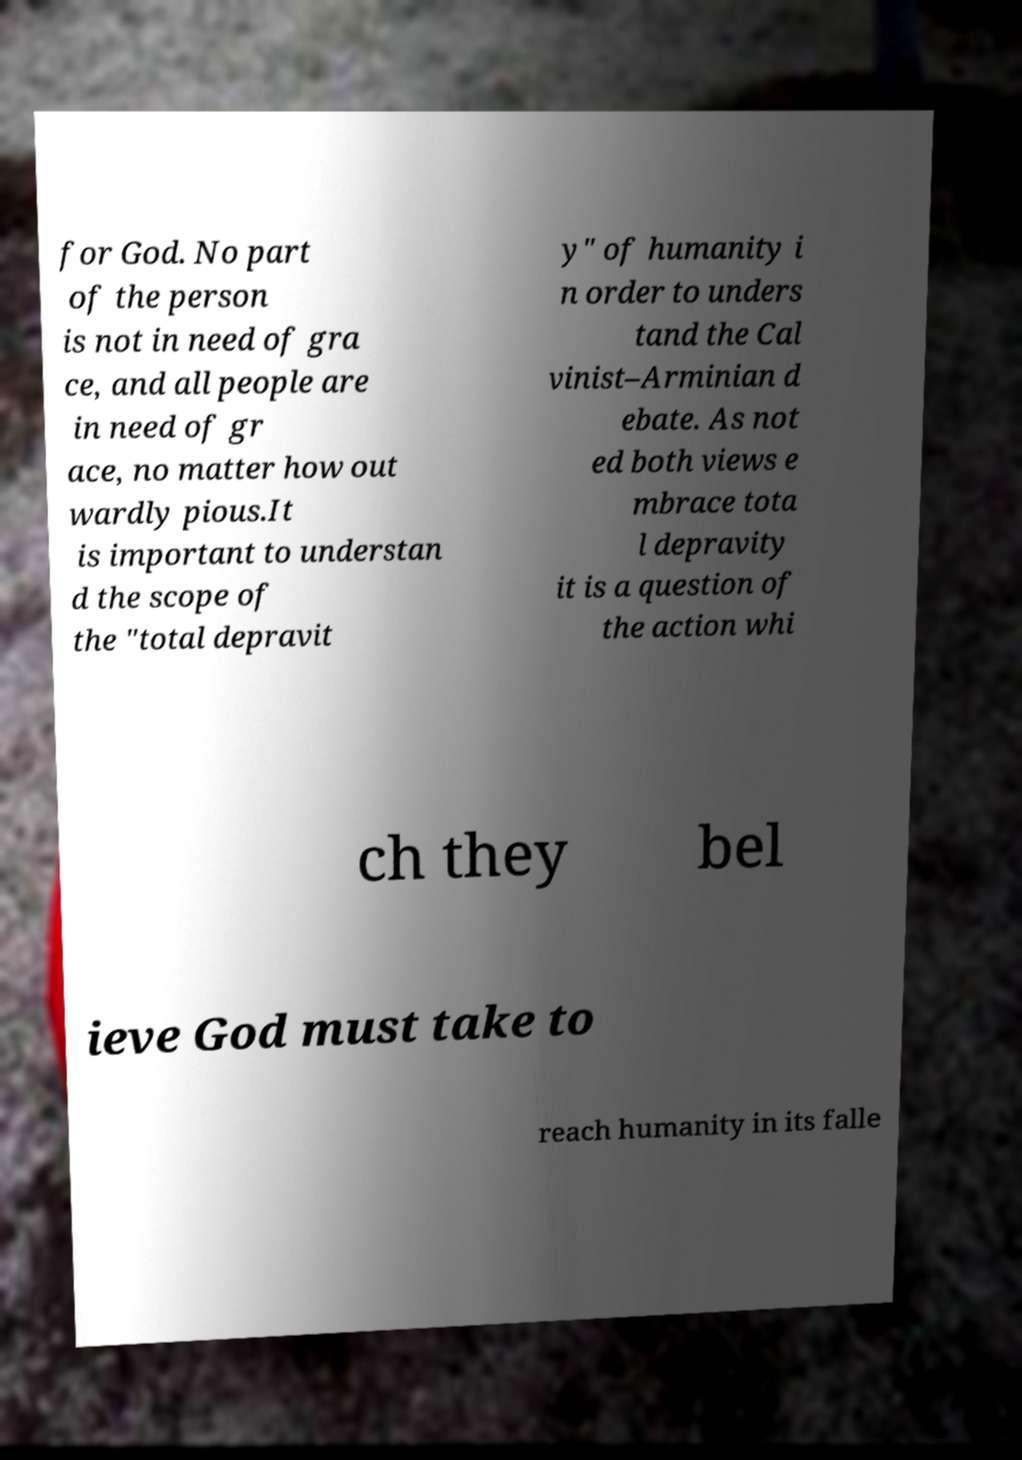Can you read and provide the text displayed in the image?This photo seems to have some interesting text. Can you extract and type it out for me? for God. No part of the person is not in need of gra ce, and all people are in need of gr ace, no matter how out wardly pious.It is important to understan d the scope of the "total depravit y" of humanity i n order to unders tand the Cal vinist–Arminian d ebate. As not ed both views e mbrace tota l depravity it is a question of the action whi ch they bel ieve God must take to reach humanity in its falle 